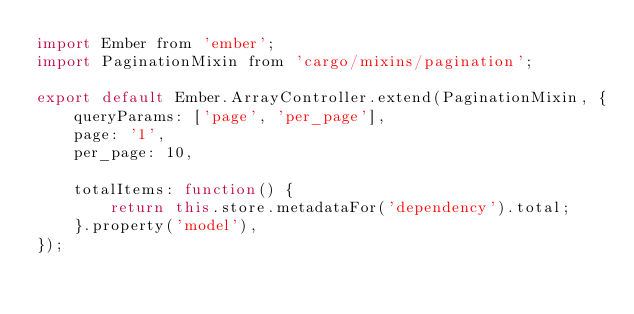<code> <loc_0><loc_0><loc_500><loc_500><_JavaScript_>import Ember from 'ember';
import PaginationMixin from 'cargo/mixins/pagination';

export default Ember.ArrayController.extend(PaginationMixin, {
    queryParams: ['page', 'per_page'],
    page: '1',
    per_page: 10,

    totalItems: function() {
        return this.store.metadataFor('dependency').total;
    }.property('model'),
});

</code> 